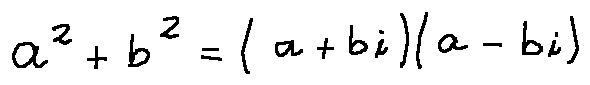<formula> <loc_0><loc_0><loc_500><loc_500>a ^ { 2 } + b ^ { 2 } = ( a + b i ) ( a - b i )</formula> 